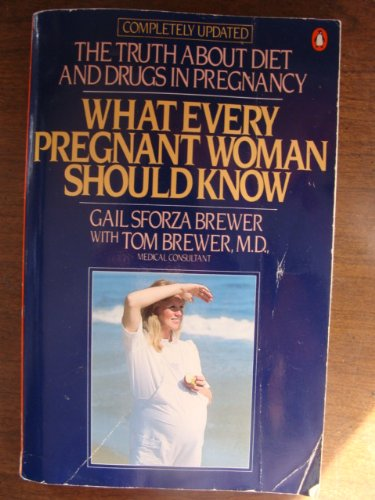Can you explain the significance of the diet information mentioned in this book? The book provides detailed knowledge on the essential nutrients needed during pregnancy, highlighting the impact of a balanced diet on both maternal and fetal health. 